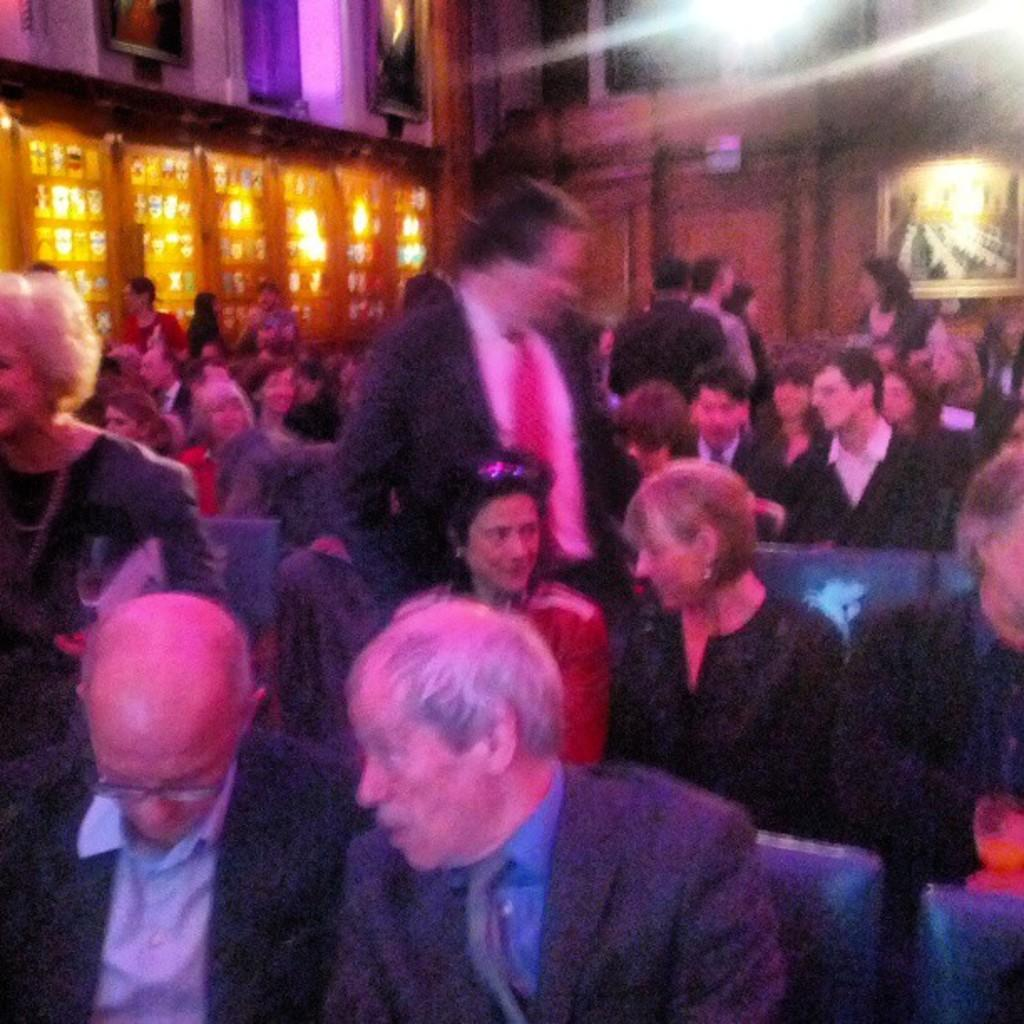How many people are in the image? There are many people in the image. What are the people doing in the image? The people are sitting on chairs. What can be seen on the wall in the image? There is a wall in the image with lights on it. What type of decorations are present in the image? There are frames present in the image. What type of brass instrument is being played by the jellyfish in the image? There are no jellyfish or brass instruments present in the image. 